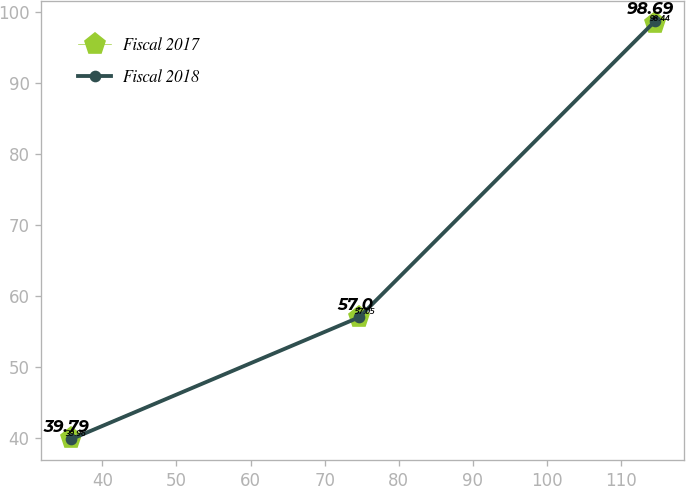Convert chart to OTSL. <chart><loc_0><loc_0><loc_500><loc_500><line_chart><ecel><fcel>Fiscal 2017<fcel>Fiscal 2018<nl><fcel>35.71<fcel>39.96<fcel>39.79<nl><fcel>74.65<fcel>57.05<fcel>57<nl><fcel>114.54<fcel>98.44<fcel>98.69<nl></chart> 